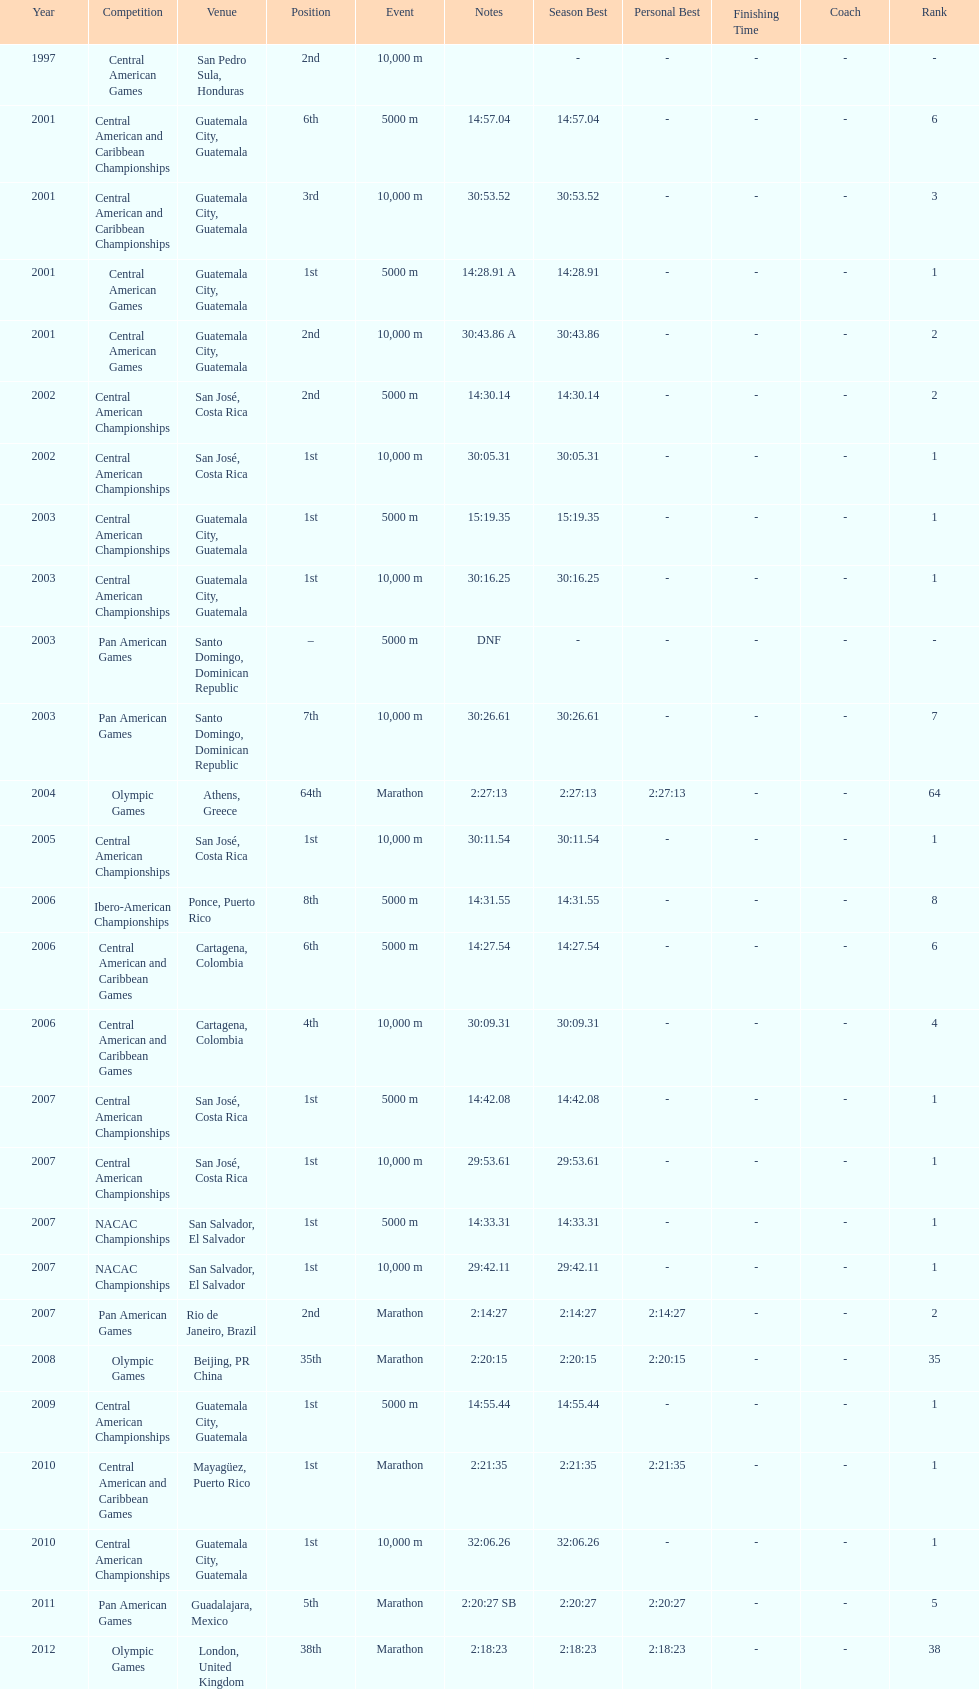How many times has the position of 1st been achieved? 12. Could you parse the entire table as a dict? {'header': ['Year', 'Competition', 'Venue', 'Position', 'Event', 'Notes', 'Season Best', 'Personal Best', 'Finishing Time', 'Coach', 'Rank'], 'rows': [['1997', 'Central American Games', 'San Pedro Sula, Honduras', '2nd', '10,000 m', '', '-', '-', '-', '-', '-'], ['2001', 'Central American and Caribbean Championships', 'Guatemala City, Guatemala', '6th', '5000 m', '14:57.04', '14:57.04', '-', '-', '-', '6'], ['2001', 'Central American and Caribbean Championships', 'Guatemala City, Guatemala', '3rd', '10,000 m', '30:53.52', '30:53.52', '-', '-', '-', '3'], ['2001', 'Central American Games', 'Guatemala City, Guatemala', '1st', '5000 m', '14:28.91 A', '14:28.91', '-', '-', '-', '1'], ['2001', 'Central American Games', 'Guatemala City, Guatemala', '2nd', '10,000 m', '30:43.86 A', '30:43.86', '-', '-', '-', '2'], ['2002', 'Central American Championships', 'San José, Costa Rica', '2nd', '5000 m', '14:30.14', '14:30.14', '-', '-', '-', '2'], ['2002', 'Central American Championships', 'San José, Costa Rica', '1st', '10,000 m', '30:05.31', '30:05.31', '-', '-', '-', '1'], ['2003', 'Central American Championships', 'Guatemala City, Guatemala', '1st', '5000 m', '15:19.35', '15:19.35', '-', '-', '-', '1'], ['2003', 'Central American Championships', 'Guatemala City, Guatemala', '1st', '10,000 m', '30:16.25', '30:16.25', '-', '-', '-', '1'], ['2003', 'Pan American Games', 'Santo Domingo, Dominican Republic', '–', '5000 m', 'DNF', '-', '-', '-', '-', '-'], ['2003', 'Pan American Games', 'Santo Domingo, Dominican Republic', '7th', '10,000 m', '30:26.61', '30:26.61', '-', '-', '-', '7'], ['2004', 'Olympic Games', 'Athens, Greece', '64th', 'Marathon', '2:27:13', '2:27:13', '2:27:13', '-', '-', '64'], ['2005', 'Central American Championships', 'San José, Costa Rica', '1st', '10,000 m', '30:11.54', '30:11.54', '-', '-', '-', '1'], ['2006', 'Ibero-American Championships', 'Ponce, Puerto Rico', '8th', '5000 m', '14:31.55', '14:31.55', '-', '-', '-', '8'], ['2006', 'Central American and Caribbean Games', 'Cartagena, Colombia', '6th', '5000 m', '14:27.54', '14:27.54', '-', '-', '-', '6'], ['2006', 'Central American and Caribbean Games', 'Cartagena, Colombia', '4th', '10,000 m', '30:09.31', '30:09.31', '-', '-', '-', '4'], ['2007', 'Central American Championships', 'San José, Costa Rica', '1st', '5000 m', '14:42.08', '14:42.08', '-', '-', '-', '1'], ['2007', 'Central American Championships', 'San José, Costa Rica', '1st', '10,000 m', '29:53.61', '29:53.61', '-', '-', '-', '1'], ['2007', 'NACAC Championships', 'San Salvador, El Salvador', '1st', '5000 m', '14:33.31', '14:33.31', '-', '-', '-', '1'], ['2007', 'NACAC Championships', 'San Salvador, El Salvador', '1st', '10,000 m', '29:42.11', '29:42.11', '-', '-', '-', '1'], ['2007', 'Pan American Games', 'Rio de Janeiro, Brazil', '2nd', 'Marathon', '2:14:27', '2:14:27', '2:14:27', '-', '-', '2'], ['2008', 'Olympic Games', 'Beijing, PR China', '35th', 'Marathon', '2:20:15', '2:20:15', '2:20:15', '-', '-', '35'], ['2009', 'Central American Championships', 'Guatemala City, Guatemala', '1st', '5000 m', '14:55.44', '14:55.44', '-', '-', '-', '1'], ['2010', 'Central American and Caribbean Games', 'Mayagüez, Puerto Rico', '1st', 'Marathon', '2:21:35', '2:21:35', '2:21:35', '-', '-', '1'], ['2010', 'Central American Championships', 'Guatemala City, Guatemala', '1st', '10,000 m', '32:06.26', '32:06.26', '-', '-', '-', '1'], ['2011', 'Pan American Games', 'Guadalajara, Mexico', '5th', 'Marathon', '2:20:27 SB', '2:20:27', '2:20:27', '-', '-', '5'], ['2012', 'Olympic Games', 'London, United Kingdom', '38th', 'Marathon', '2:18:23', '2:18:23', '2:18:23', '-', '-', '38']]} 